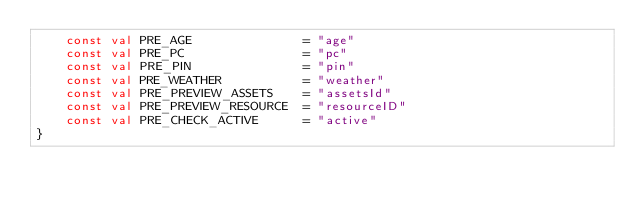Convert code to text. <code><loc_0><loc_0><loc_500><loc_500><_Kotlin_>    const val PRE_AGE               = "age"
    const val PRE_PC                = "pc"
    const val PRE_PIN               = "pin"
    const val PRE_WEATHER           = "weather"
    const val PRE_PREVIEW_ASSETS    = "assetsId"
    const val PRE_PREVIEW_RESOURCE  = "resourceID"
    const val PRE_CHECK_ACTIVE      = "active"
}

</code> 